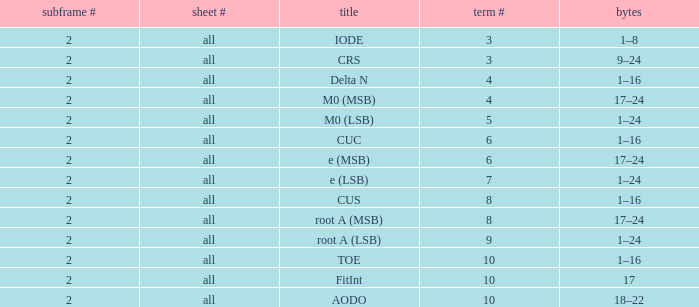What is the total subframe count with Bits of 18–22? 2.0. 